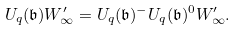<formula> <loc_0><loc_0><loc_500><loc_500>U _ { q } ( \mathfrak { b } ) W _ { \infty } ^ { \prime } = U _ { q } ( \mathfrak { b } ) ^ { - } U _ { q } ( \mathfrak { b } ) ^ { 0 } W _ { \infty } ^ { \prime } .</formula> 